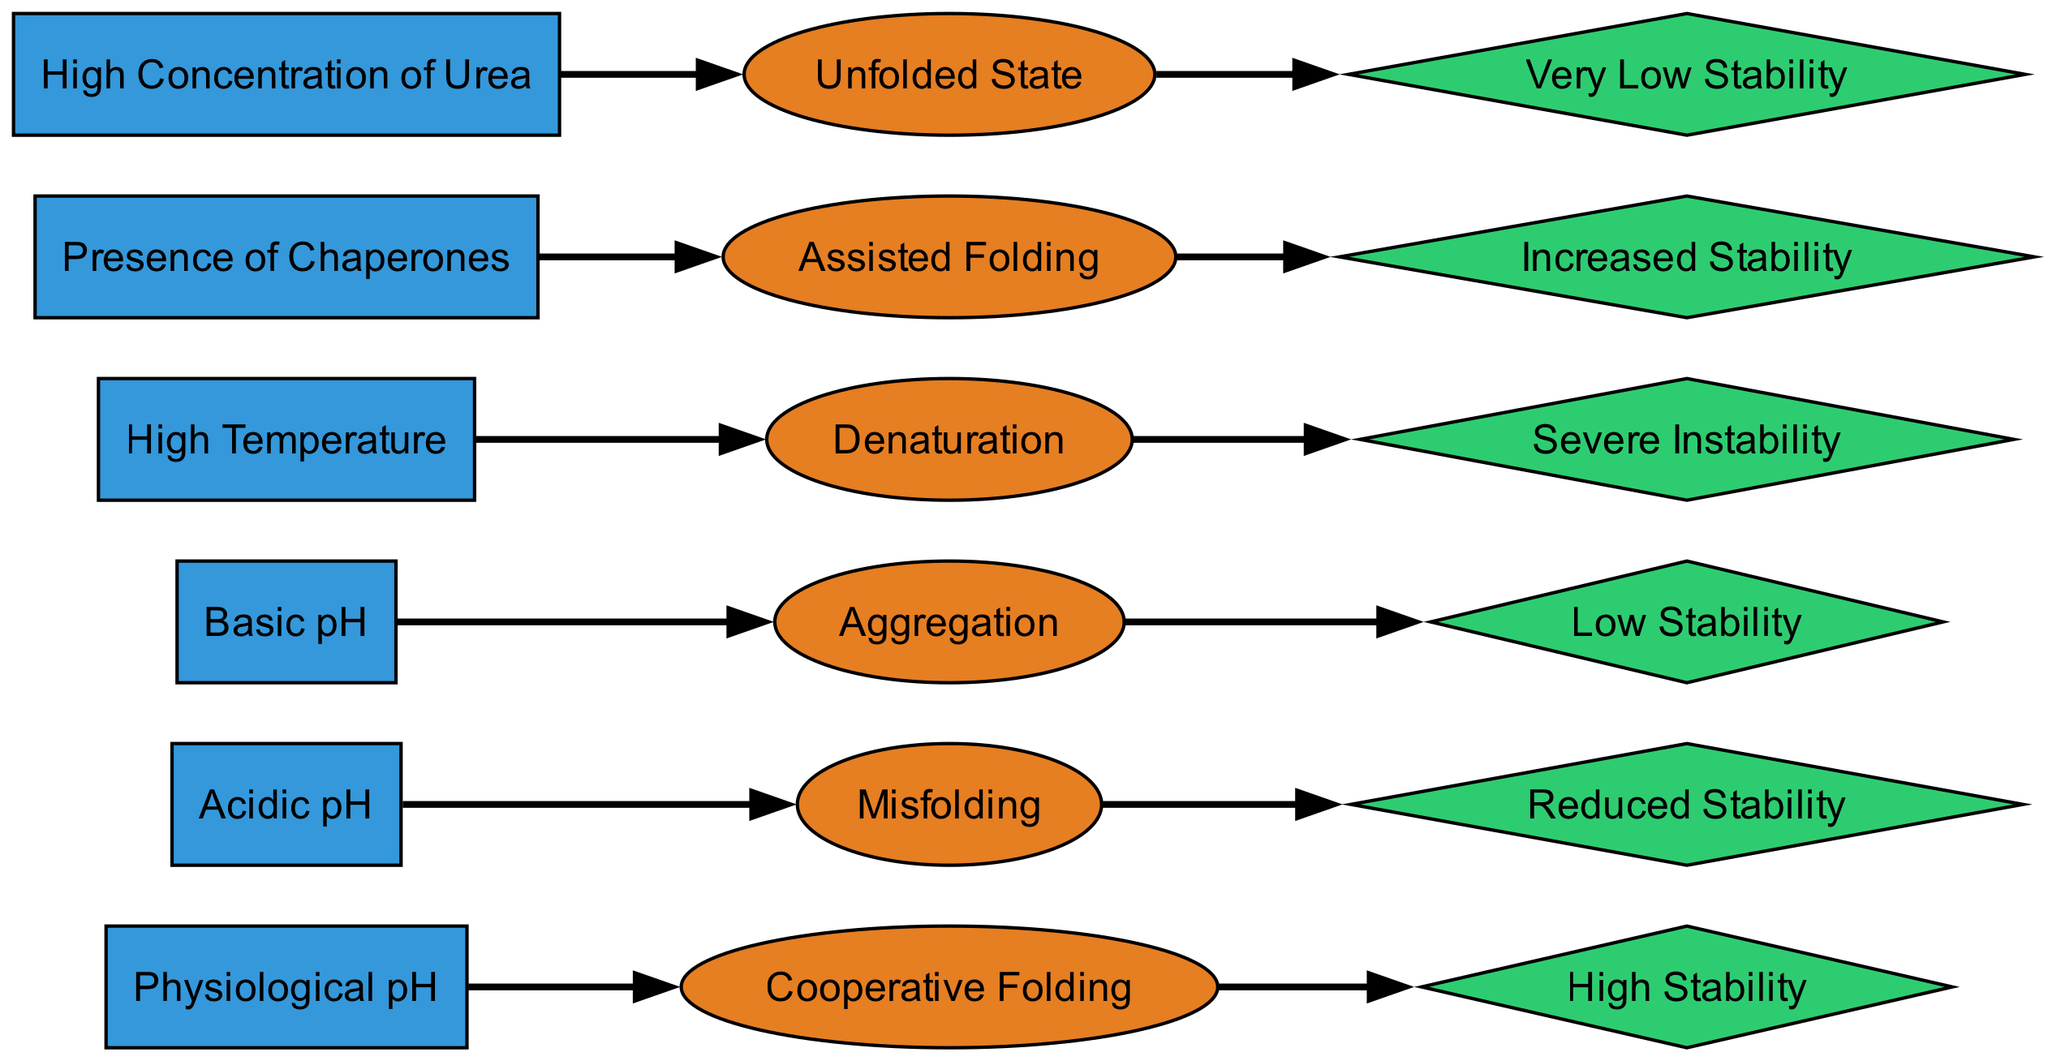What folding pathway is observed under physiological pH? The diagram shows a directed relationship from the node "Physiological pH" to the node "Cooperative Folding". Therefore, under physiological pH, the folding pathway is "Cooperative Folding".
Answer: Cooperative Folding How many different stability impacts are there in the diagram? By counting the unique nodes representing stability impacts, we find "High Stability," "Reduced Stability," "Low Stability," "Severe Instability," "Increased Stability," and "Very Low Stability," which totals six different stability impacts.
Answer: 6 Which condition leads to very low stability? The diagram indicates an arrow from "High Concentration of Urea" to "Unfolded State," which is also labeled "Very Low Stability." Thus, the condition that leads to very low stability is "High Concentration of Urea."
Answer: High Concentration of Urea What is the relationship between presence of chaperones and folding pathway? The diagram shows that "Presence of Chaperones" connects to "Assisted Folding," indicating that the presence of chaperones implies or influences the assisted folding pathway.
Answer: Assisted Folding What is the stability impact associated with high temperature? Following the directed path, "High Temperature" leads to "Denaturation," which is linked to "Severe Instability." Therefore, the stability impact associated with high temperature is "Severe Instability."
Answer: Severe Instability Which condition is associated with misfolding? From the diagram, "Acidic pH" points to "Misfolding," making this the condition associated specifically with misfolding.
Answer: Acidic pH Which folding pathway corresponds to basic pH? The directed line shows that "Basic pH" is connected to the pathway labeled "Aggregation." Therefore, the folding pathway corresponding to basic pH is "Aggregation."
Answer: Aggregation What are the three states with low stability impacts? The diagram shows three nodes connected to low stability impacts: "Low Stability," "Reduced Stability," and "Very Low Stability." These together make up the impact states that can be classified as low.
Answer: Low Stability, Reduced Stability, Very Low Stability 